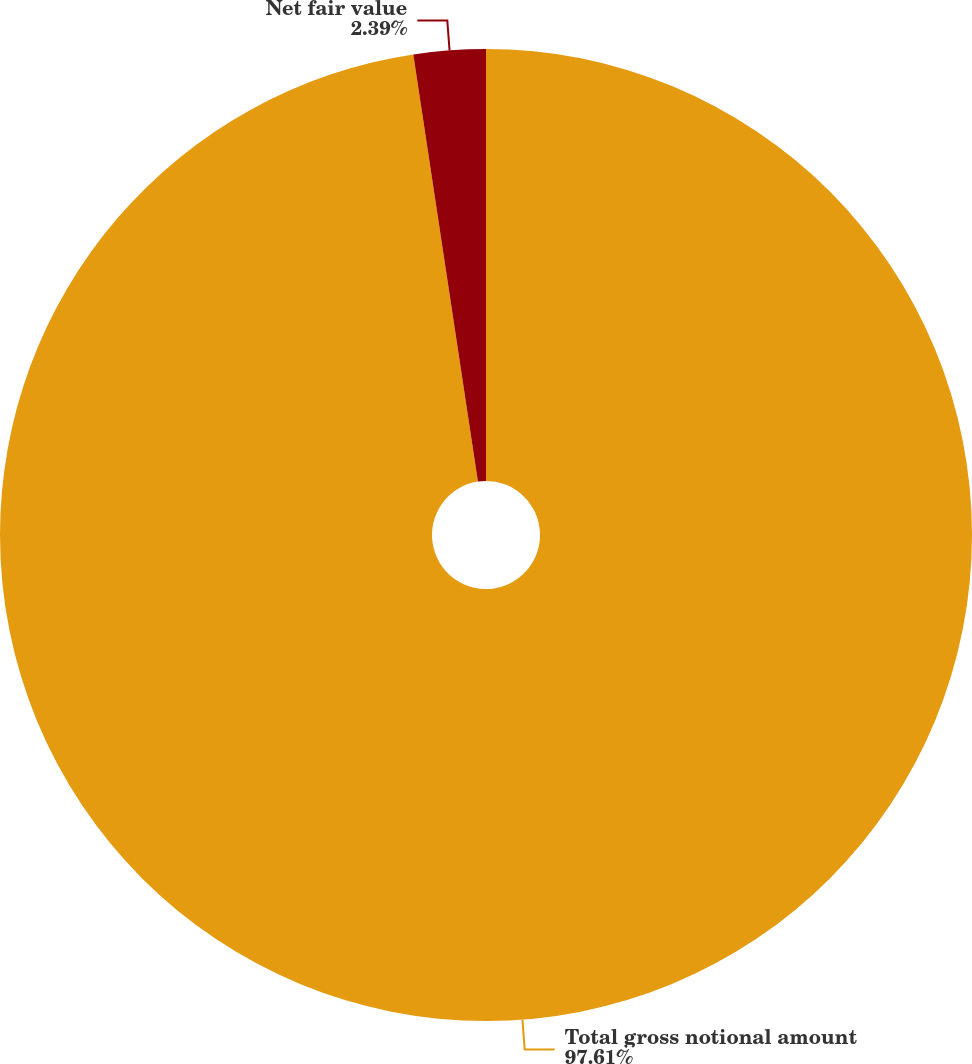Convert chart to OTSL. <chart><loc_0><loc_0><loc_500><loc_500><pie_chart><fcel>Total gross notional amount<fcel>Net fair value<nl><fcel>97.61%<fcel>2.39%<nl></chart> 